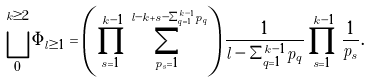Convert formula to latex. <formula><loc_0><loc_0><loc_500><loc_500>\bigsqcup _ { 0 } ^ { k \geq 2 } \Phi _ { l \geq 1 } = \left ( \prod _ { s = 1 } ^ { k - 1 } \sum _ { p _ { s } = 1 } ^ { l - k + s - \Sigma _ { q = 1 } ^ { k - 1 } p _ { q } } \right ) \frac { 1 } { l - \Sigma _ { q = 1 } ^ { k - 1 } p _ { q } } \prod _ { s = 1 } ^ { k - 1 } \frac { 1 } { p _ { s } } .</formula> 